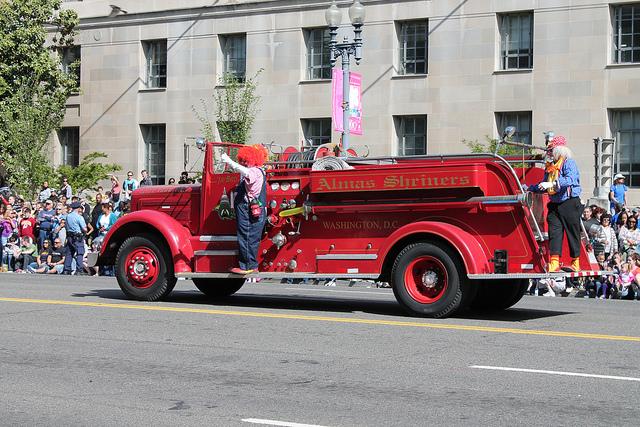How many tires does the truck have?
Answer briefly. 4. What color is the truck?
Concise answer only. Red. Who is driving the truck?
Keep it brief. Clown. How many wheels are on this truck?
Write a very short answer. 4. Could this be a Masonic order?
Quick response, please. No. What is written on top of the truck?
Answer briefly. Almas shriners. How many tires can you see on the truck?
Give a very brief answer. 4. 